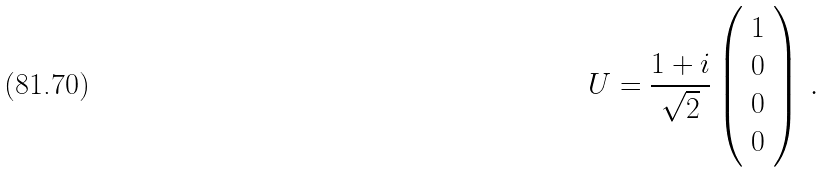<formula> <loc_0><loc_0><loc_500><loc_500>U = \frac { 1 + i } { \sqrt { 2 } } \left ( \begin{array} { c } 1 \\ 0 \\ 0 \\ 0 \end{array} \right ) \, .</formula> 